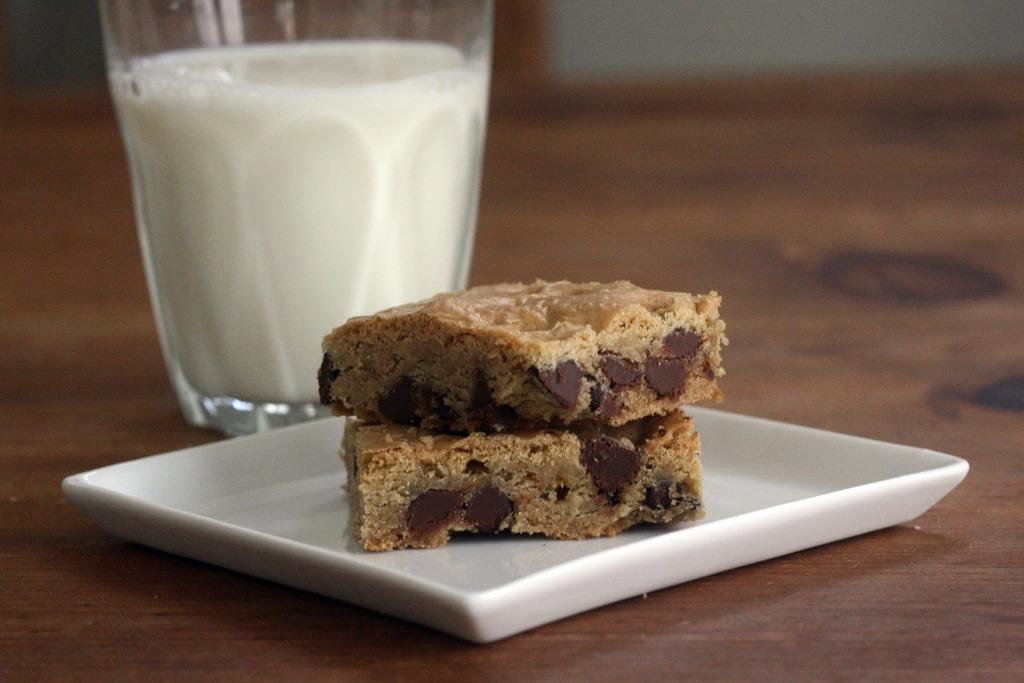What piece of furniture is present in the image? There is a table in the image. What is placed on the table? There is a plate and a glass containing a liquid on the table. What type of food can be seen on the plate? There are bread pieces on the plate. How many cars are parked next to the table in the image? There are no cars present in the image; it only features a table, a plate, a glass, and bread pieces. Can you tell me if the bread pieces are smiling in the image? Bread pieces do not have facial expressions and therefore cannot smile. 